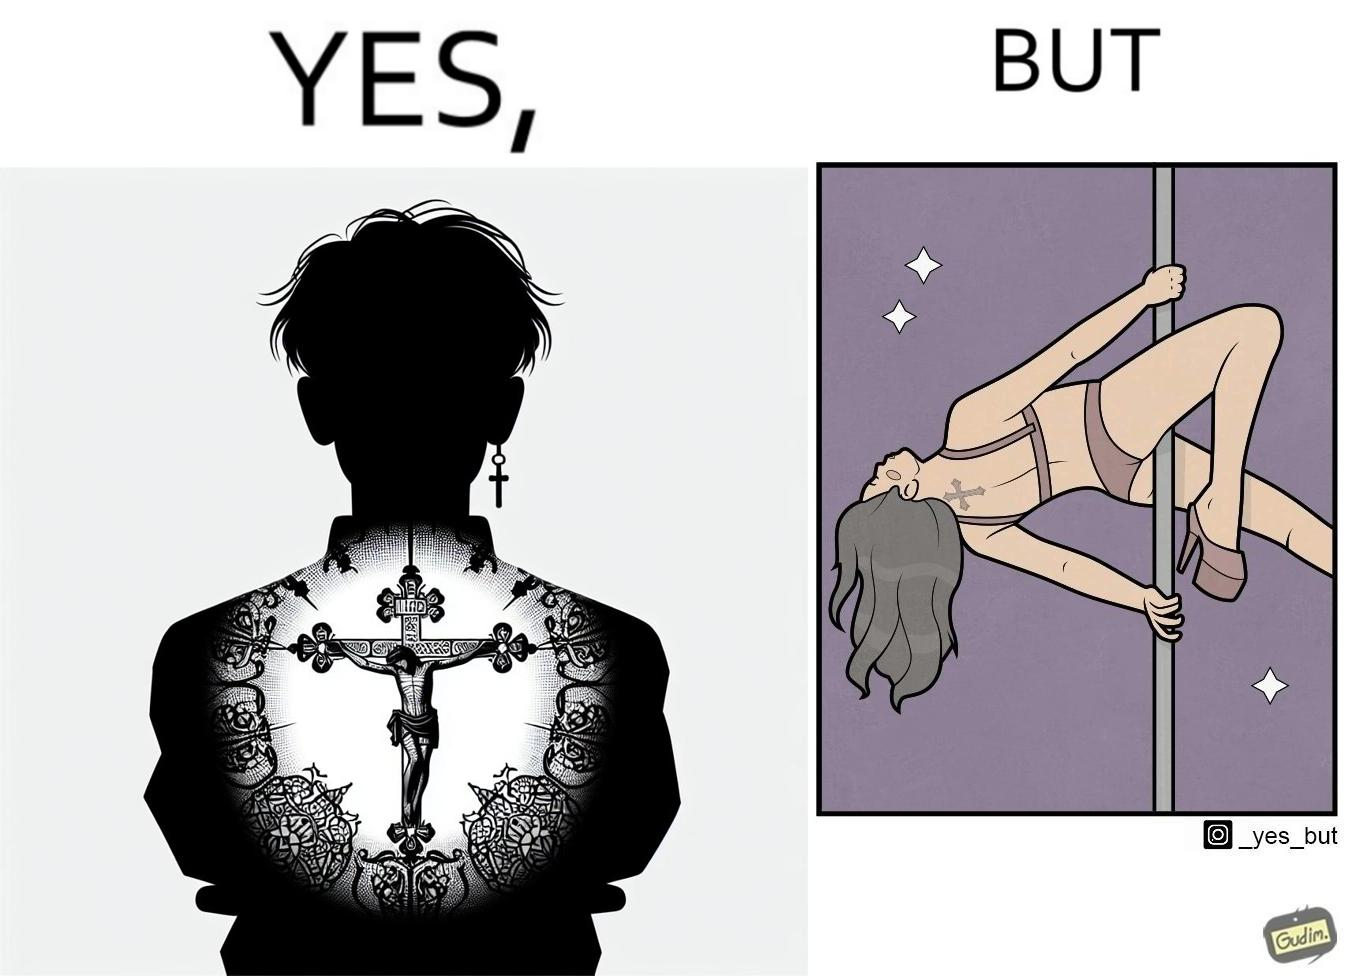Describe the content of this image. This image may present two different ideas, firstly even she is such a believer in god that she has got a tatto of holy cross symbol on her back but her situations have forced her to do a job at a bar or some place performing pole dance and secondly she is using a religious symbol to glorify her look so that more people acknowledge her dance and give her some money 